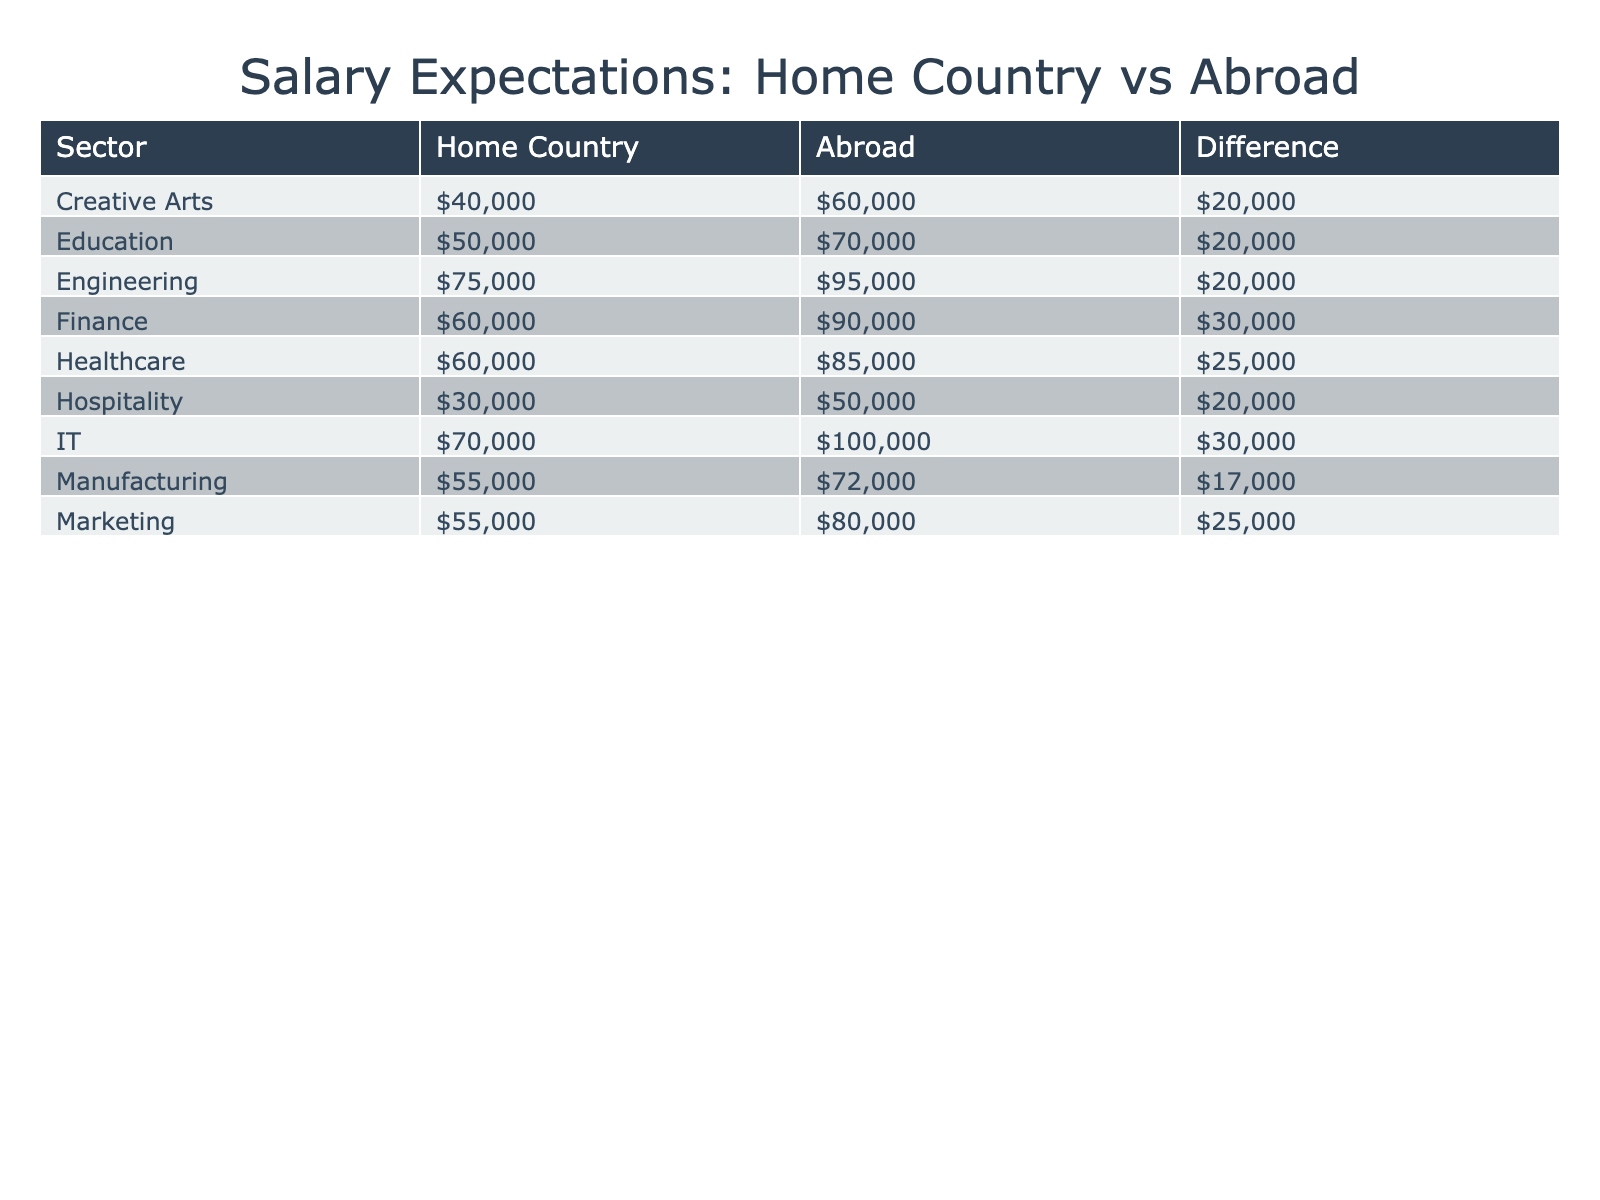What is the highest salary expectation for the IT sector? The table lists the salary expectations for the IT sector in both home country and abroad. The salary expectation abroad is 100,000 USD, which is the highest value for this sector.
Answer: 100000 Which sector has the largest salary difference between home country and abroad? By examining the 'Difference' column in the table, we find that the IT sector has the largest difference, which is 30,000 USD (100,000 - 70,000).
Answer: IT Is the salary expectation for the Creative Arts sector higher abroad than in the home country? In the table, the salary expectation for Creative Arts at home is 40,000 USD and abroad is 60,000 USD. Since 60,000 is greater than 40,000, the statement is true.
Answer: Yes What is the average salary expectation for all sectors in the home country? To find the average, we add the salary expectations for home country across all sectors: 75,000 + 60,000 + 70,000 + 50,000 + 55,000 + 60,000 + 40,000 + 55,000 + 30,000 = 600,000. Dividing by the number of sectors (9), the average is 66,667 USD (600,000 / 9).
Answer: 66667 Are salary expectations for the Hospitality sector equal at home and abroad? By checking the table, the salary for the Hospitality sector in the home country is 30,000 USD, while abroad it is 50,000 USD. Since these values are not equal, the statement is false.
Answer: No What is the total salary expectation for the Healthcare and Manufacturing sectors in the home country? We add the salary expectations for these two sectors in the home country: 60,000 (Healthcare) + 55,000 (Manufacturing) = 115,000 USD as the total expectation.
Answer: 115000 Is it true that all sectors have higher salaries abroad compared to their home country? Looking at the 'Difference' column, we see some sectors have higher salaries abroad, but the Creative Arts and Hospitality have lower salaries in the home country than abroad. Therefore, the statement is false.
Answer: No Which sector has the lowest salary expectation in the home country? The table shows that the Hospitality sector has the lowest salary expectation at home with a value of 30,000 USD.
Answer: Hospitality What is the salary expectation difference for the Marketing sector? The difference for the Marketing sector can be calculated as follows: 80,000 (abroad) - 55,000 (home country) = 25,000 USD.
Answer: 25000 